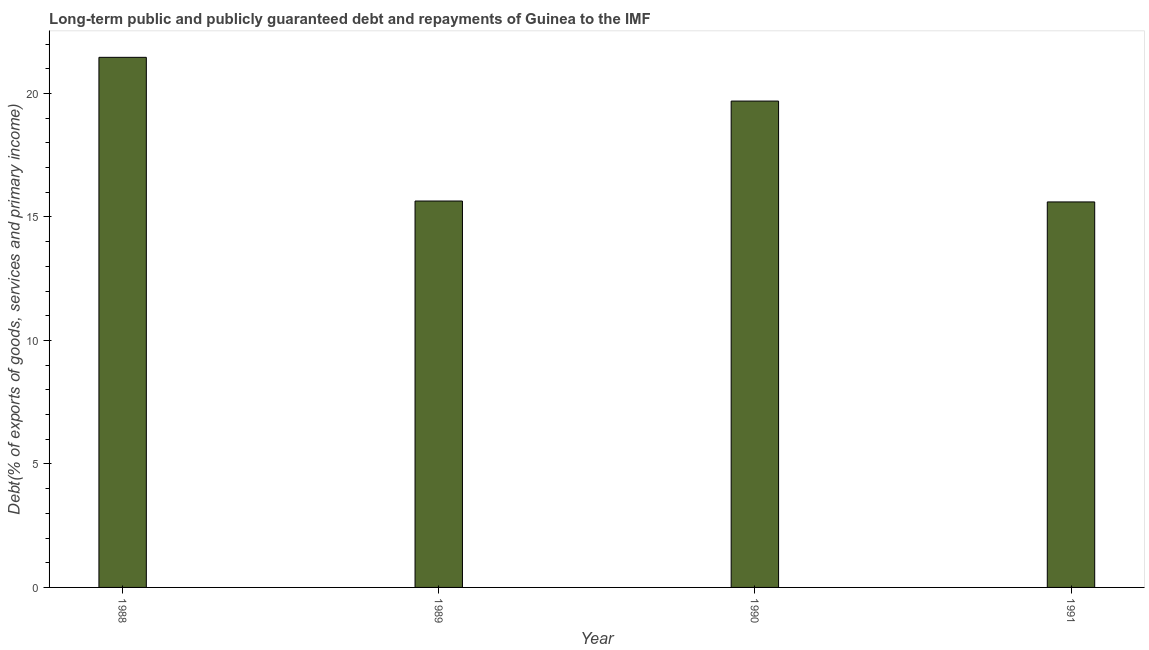Does the graph contain any zero values?
Provide a succinct answer. No. Does the graph contain grids?
Your answer should be very brief. No. What is the title of the graph?
Give a very brief answer. Long-term public and publicly guaranteed debt and repayments of Guinea to the IMF. What is the label or title of the Y-axis?
Your answer should be compact. Debt(% of exports of goods, services and primary income). What is the debt service in 1990?
Offer a terse response. 19.69. Across all years, what is the maximum debt service?
Provide a short and direct response. 21.46. Across all years, what is the minimum debt service?
Provide a succinct answer. 15.61. In which year was the debt service maximum?
Provide a succinct answer. 1988. In which year was the debt service minimum?
Offer a terse response. 1991. What is the sum of the debt service?
Keep it short and to the point. 72.4. What is the difference between the debt service in 1990 and 1991?
Ensure brevity in your answer.  4.08. What is the median debt service?
Your response must be concise. 17.67. Do a majority of the years between 1990 and 1989 (inclusive) have debt service greater than 20 %?
Ensure brevity in your answer.  No. What is the ratio of the debt service in 1990 to that in 1991?
Offer a terse response. 1.26. What is the difference between the highest and the second highest debt service?
Make the answer very short. 1.77. What is the difference between the highest and the lowest debt service?
Keep it short and to the point. 5.85. In how many years, is the debt service greater than the average debt service taken over all years?
Provide a succinct answer. 2. How many bars are there?
Provide a short and direct response. 4. What is the difference between two consecutive major ticks on the Y-axis?
Give a very brief answer. 5. Are the values on the major ticks of Y-axis written in scientific E-notation?
Give a very brief answer. No. What is the Debt(% of exports of goods, services and primary income) in 1988?
Keep it short and to the point. 21.46. What is the Debt(% of exports of goods, services and primary income) of 1989?
Offer a terse response. 15.64. What is the Debt(% of exports of goods, services and primary income) of 1990?
Give a very brief answer. 19.69. What is the Debt(% of exports of goods, services and primary income) in 1991?
Your answer should be very brief. 15.61. What is the difference between the Debt(% of exports of goods, services and primary income) in 1988 and 1989?
Make the answer very short. 5.82. What is the difference between the Debt(% of exports of goods, services and primary income) in 1988 and 1990?
Make the answer very short. 1.77. What is the difference between the Debt(% of exports of goods, services and primary income) in 1988 and 1991?
Provide a short and direct response. 5.85. What is the difference between the Debt(% of exports of goods, services and primary income) in 1989 and 1990?
Keep it short and to the point. -4.05. What is the difference between the Debt(% of exports of goods, services and primary income) in 1989 and 1991?
Provide a succinct answer. 0.04. What is the difference between the Debt(% of exports of goods, services and primary income) in 1990 and 1991?
Your response must be concise. 4.08. What is the ratio of the Debt(% of exports of goods, services and primary income) in 1988 to that in 1989?
Your answer should be compact. 1.37. What is the ratio of the Debt(% of exports of goods, services and primary income) in 1988 to that in 1990?
Provide a short and direct response. 1.09. What is the ratio of the Debt(% of exports of goods, services and primary income) in 1988 to that in 1991?
Your answer should be compact. 1.38. What is the ratio of the Debt(% of exports of goods, services and primary income) in 1989 to that in 1990?
Your response must be concise. 0.79. What is the ratio of the Debt(% of exports of goods, services and primary income) in 1989 to that in 1991?
Offer a terse response. 1. What is the ratio of the Debt(% of exports of goods, services and primary income) in 1990 to that in 1991?
Keep it short and to the point. 1.26. 